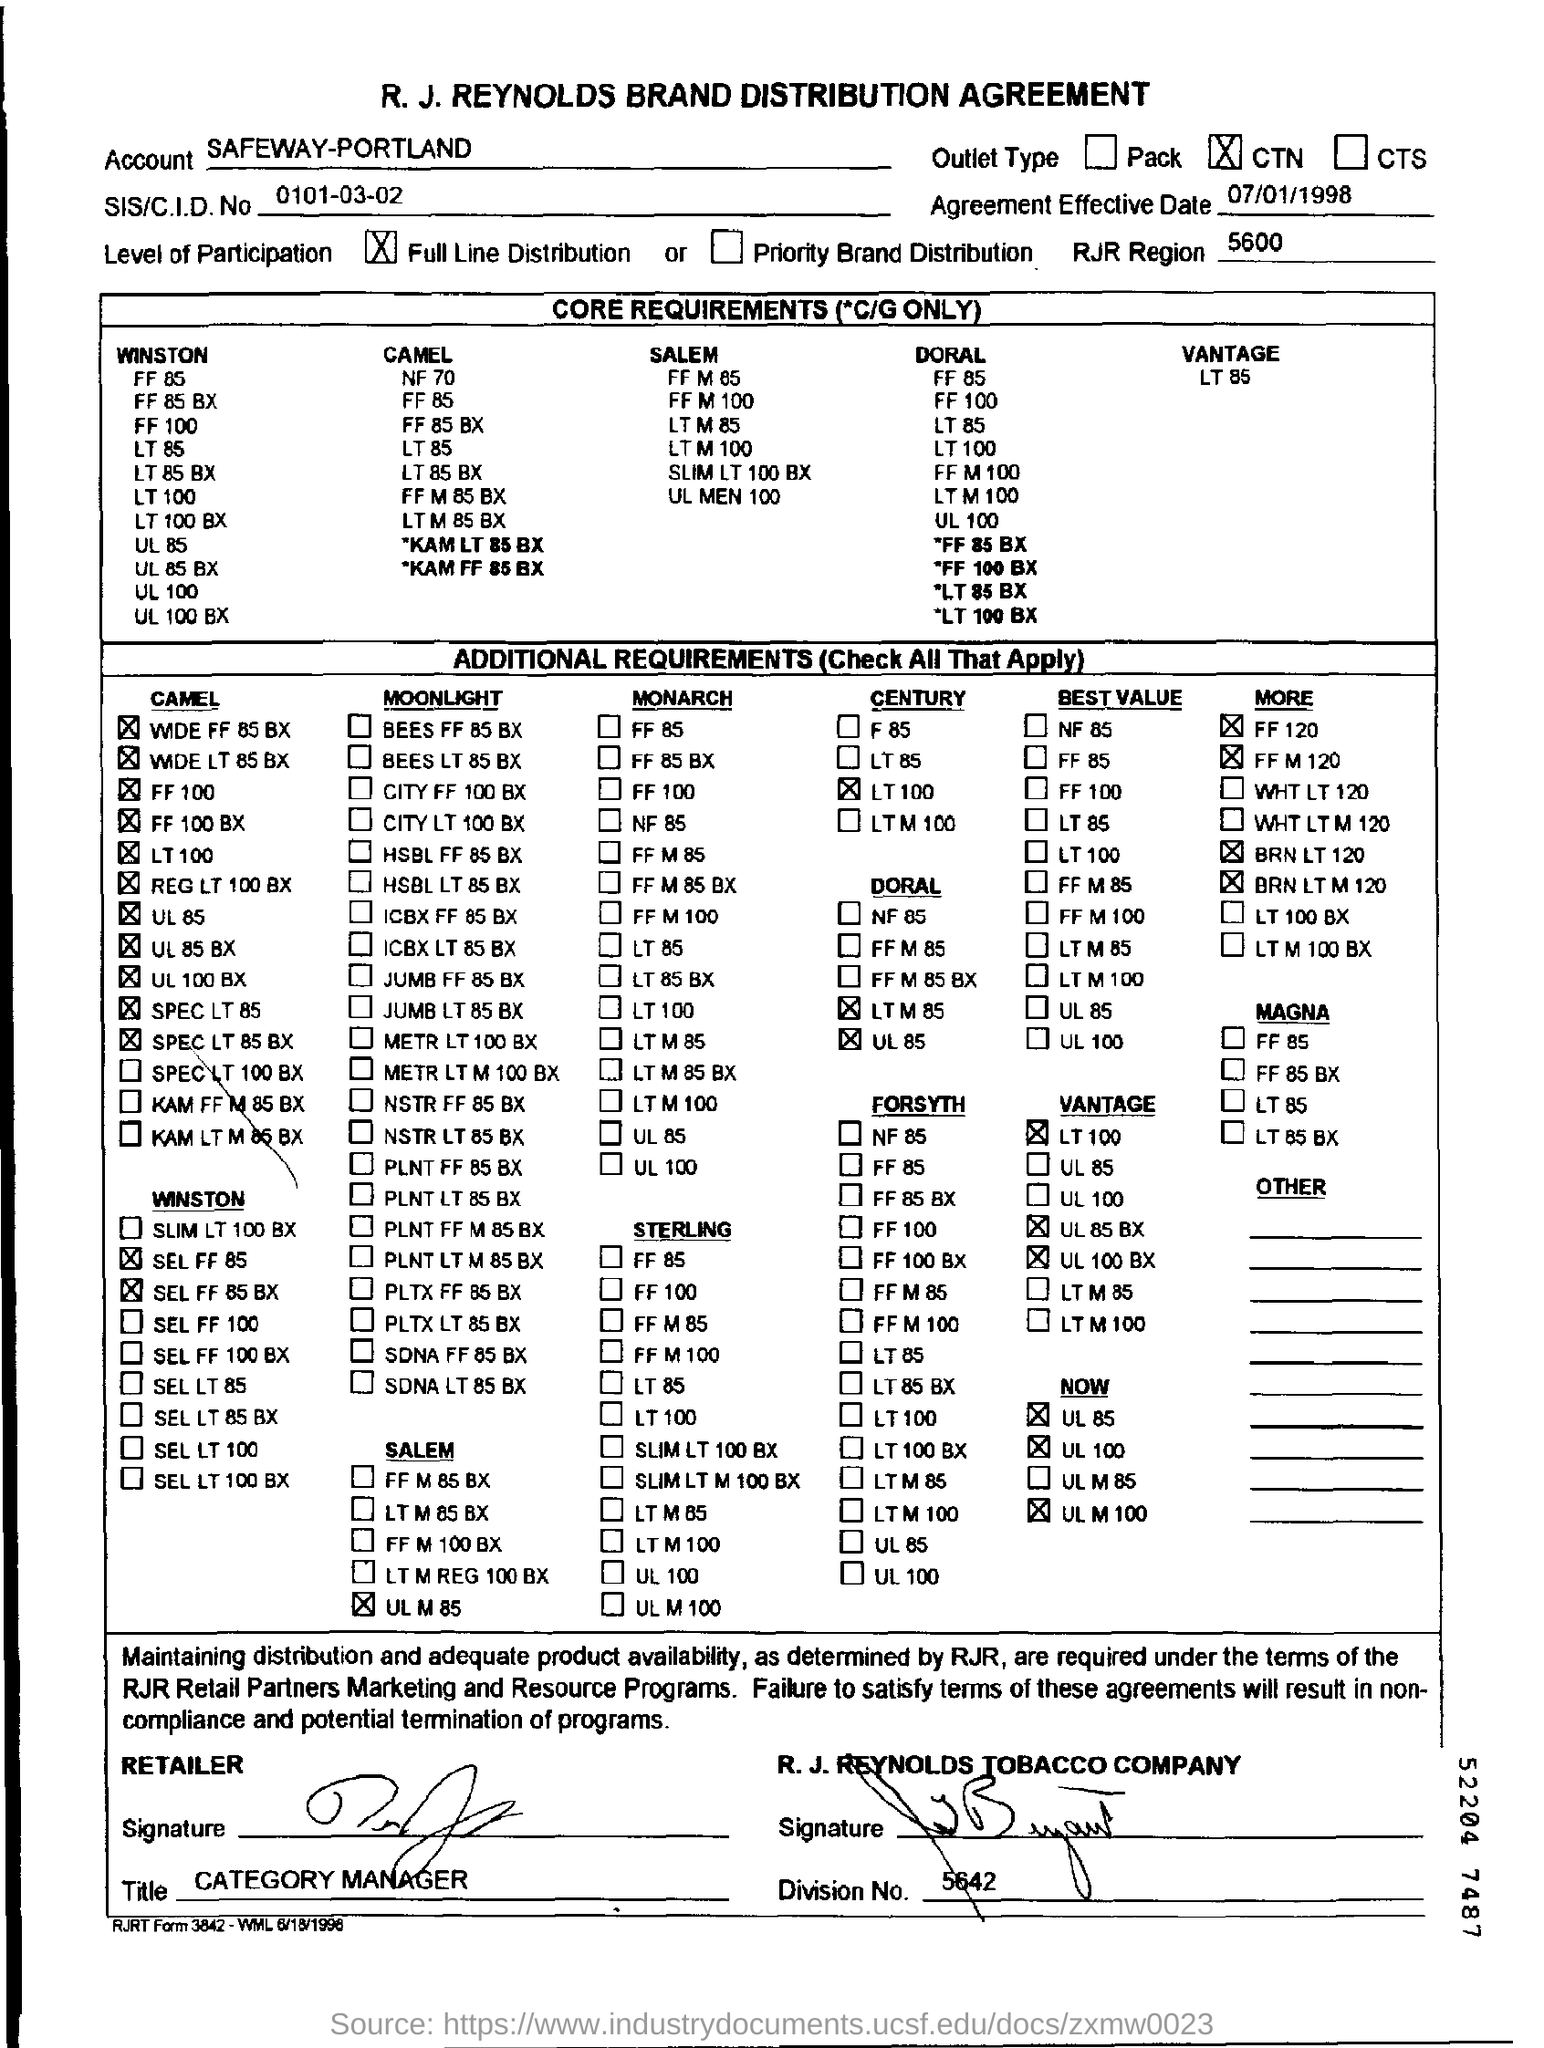Point out several critical features in this image. The level of participation as per the document is "Full Line Distribution. The RJR region is a geographical area with a number of 5600. The agreement's effective date is July 1, 1998. The company name that appears at the top of the document is R.J. Reynolds Brand Distribution Agreement. The SIS/CID number is 0101-03-02... 